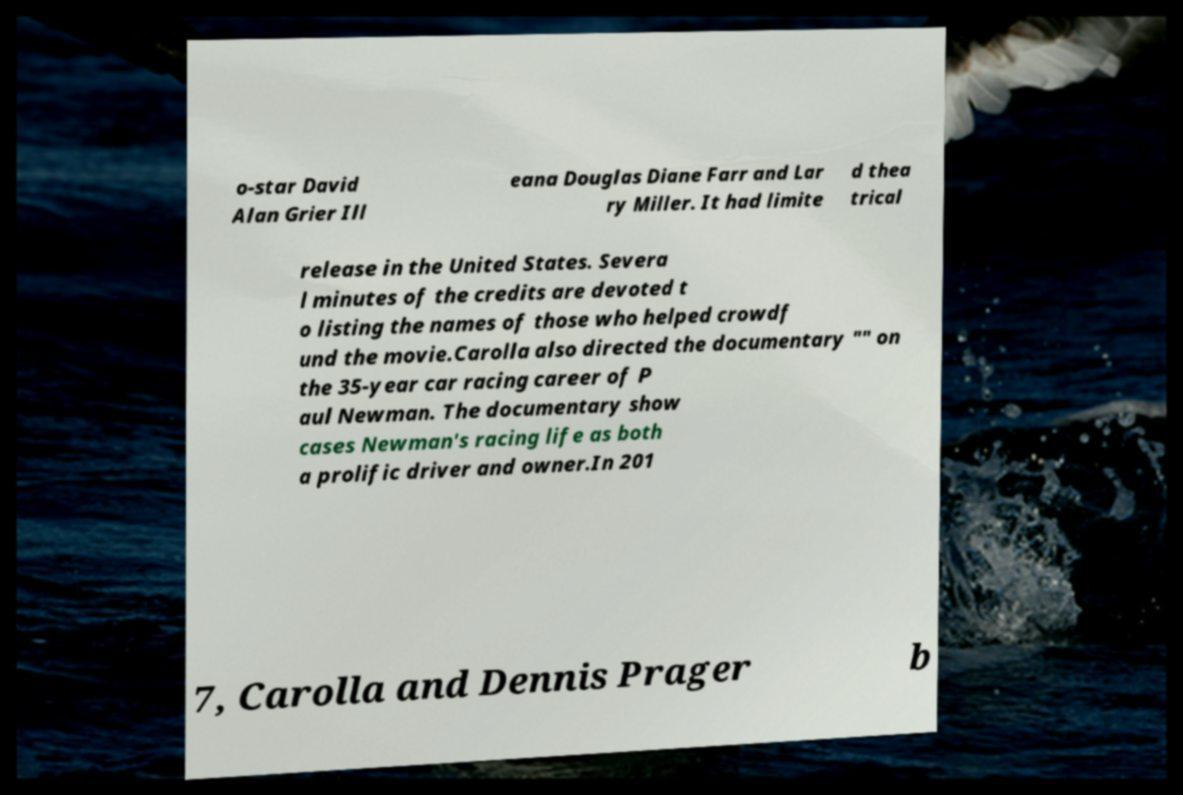For documentation purposes, I need the text within this image transcribed. Could you provide that? o-star David Alan Grier Ill eana Douglas Diane Farr and Lar ry Miller. It had limite d thea trical release in the United States. Severa l minutes of the credits are devoted t o listing the names of those who helped crowdf und the movie.Carolla also directed the documentary "" on the 35-year car racing career of P aul Newman. The documentary show cases Newman's racing life as both a prolific driver and owner.In 201 7, Carolla and Dennis Prager b 